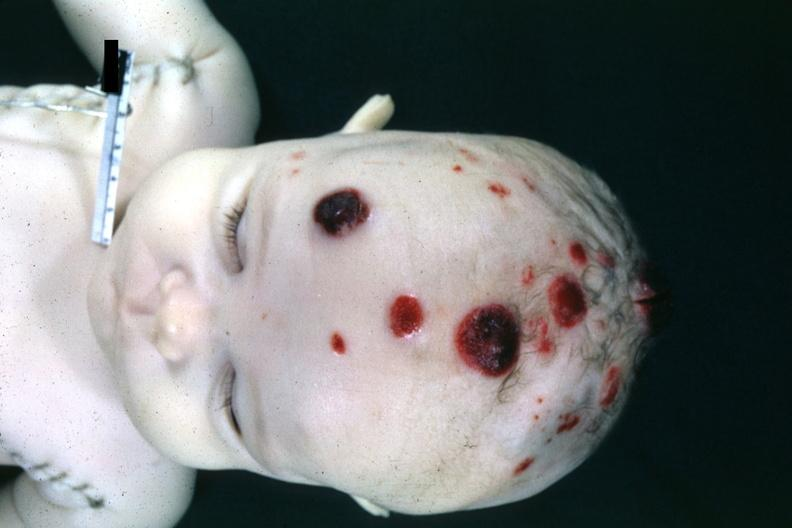s lymphoblastic lymphoma present?
Answer the question using a single word or phrase. Yes 